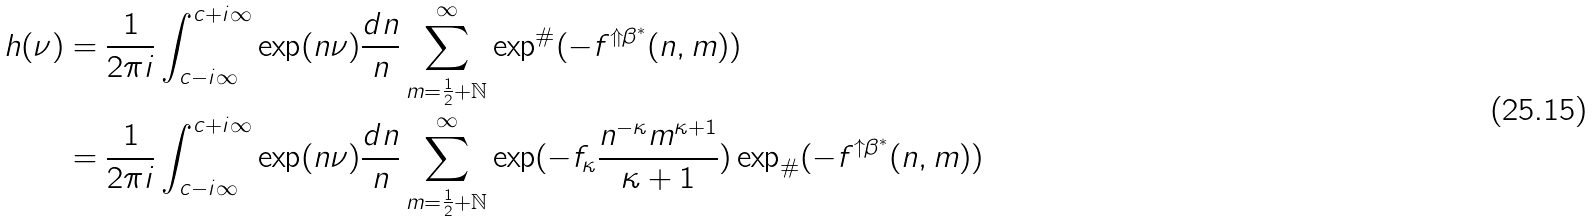<formula> <loc_0><loc_0><loc_500><loc_500>h ( \nu ) & = \frac { 1 } { 2 \pi i } \int ^ { c + i \infty } _ { c - i \infty } \exp ( n \nu ) \frac { d n } { n } \sum ^ { \infty } _ { m = \frac { 1 } { 2 } + \mathbb { N } } \exp ^ { \# } ( - f ^ { \Uparrow \beta ^ { * } } ( n , m ) ) \\ & = \frac { 1 } { 2 \pi i } \int ^ { c + i \infty } _ { c - i \infty } \exp ( n \nu ) \frac { d n } { n } \sum ^ { \infty } _ { m = \frac { 1 } { 2 } + \mathbb { N } } \exp ( - f _ { \kappa } \frac { n ^ { - \kappa } m ^ { \kappa + 1 } } { \kappa + 1 } ) \exp _ { \# } ( - f ^ { \uparrow \beta ^ { * } } ( n , m ) )</formula> 